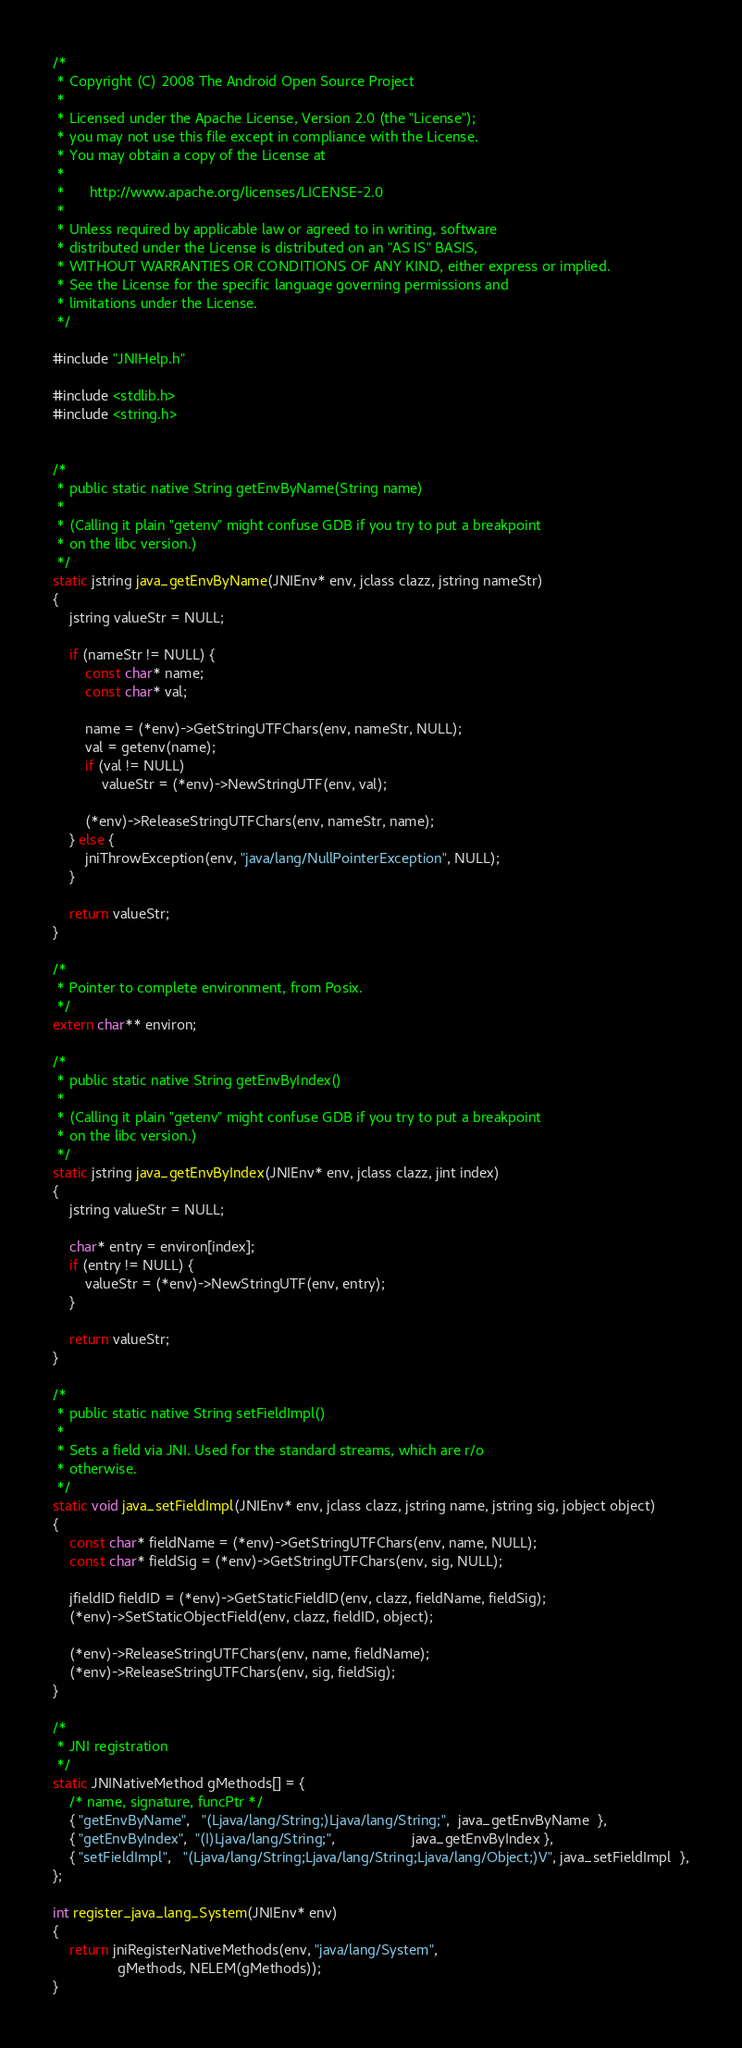Convert code to text. <code><loc_0><loc_0><loc_500><loc_500><_C_>/*
 * Copyright (C) 2008 The Android Open Source Project
 *
 * Licensed under the Apache License, Version 2.0 (the "License");
 * you may not use this file except in compliance with the License.
 * You may obtain a copy of the License at
 *
 *      http://www.apache.org/licenses/LICENSE-2.0
 *
 * Unless required by applicable law or agreed to in writing, software
 * distributed under the License is distributed on an "AS IS" BASIS,
 * WITHOUT WARRANTIES OR CONDITIONS OF ANY KIND, either express or implied.
 * See the License for the specific language governing permissions and
 * limitations under the License.
 */

#include "JNIHelp.h"

#include <stdlib.h>
#include <string.h>


/*
 * public static native String getEnvByName(String name)
 *
 * (Calling it plain "getenv" might confuse GDB if you try to put a breakpoint
 * on the libc version.)
 */
static jstring java_getEnvByName(JNIEnv* env, jclass clazz, jstring nameStr)
{
    jstring valueStr = NULL;

    if (nameStr != NULL) {
        const char* name;
        const char* val;

        name = (*env)->GetStringUTFChars(env, nameStr, NULL);
        val = getenv(name);
        if (val != NULL)
            valueStr = (*env)->NewStringUTF(env, val);

        (*env)->ReleaseStringUTFChars(env, nameStr, name);
    } else {
        jniThrowException(env, "java/lang/NullPointerException", NULL);
    }

    return valueStr;
}

/*
 * Pointer to complete environment, from Posix.
 */
extern char** environ;

/*
 * public static native String getEnvByIndex()
 *
 * (Calling it plain "getenv" might confuse GDB if you try to put a breakpoint
 * on the libc version.)
 */
static jstring java_getEnvByIndex(JNIEnv* env, jclass clazz, jint index)
{
    jstring valueStr = NULL;

    char* entry = environ[index];
    if (entry != NULL) {
        valueStr = (*env)->NewStringUTF(env, entry);
    }

    return valueStr;
}

/*
 * public static native String setFieldImpl()
 *
 * Sets a field via JNI. Used for the standard streams, which are r/o
 * otherwise.
 */
static void java_setFieldImpl(JNIEnv* env, jclass clazz, jstring name, jstring sig, jobject object)
{
    const char* fieldName = (*env)->GetStringUTFChars(env, name, NULL);
    const char* fieldSig = (*env)->GetStringUTFChars(env, sig, NULL);

    jfieldID fieldID = (*env)->GetStaticFieldID(env, clazz, fieldName, fieldSig);
    (*env)->SetStaticObjectField(env, clazz, fieldID, object);
    
    (*env)->ReleaseStringUTFChars(env, name, fieldName);
    (*env)->ReleaseStringUTFChars(env, sig, fieldSig);
}

/*
 * JNI registration
 */
static JNINativeMethod gMethods[] = {
    /* name, signature, funcPtr */
    { "getEnvByName",   "(Ljava/lang/String;)Ljava/lang/String;",  java_getEnvByName  },
    { "getEnvByIndex",  "(I)Ljava/lang/String;",                   java_getEnvByIndex },
    { "setFieldImpl",   "(Ljava/lang/String;Ljava/lang/String;Ljava/lang/Object;)V", java_setFieldImpl  },
};

int register_java_lang_System(JNIEnv* env)
{
	return jniRegisterNativeMethods(env, "java/lang/System",
                gMethods, NELEM(gMethods));
}

</code> 